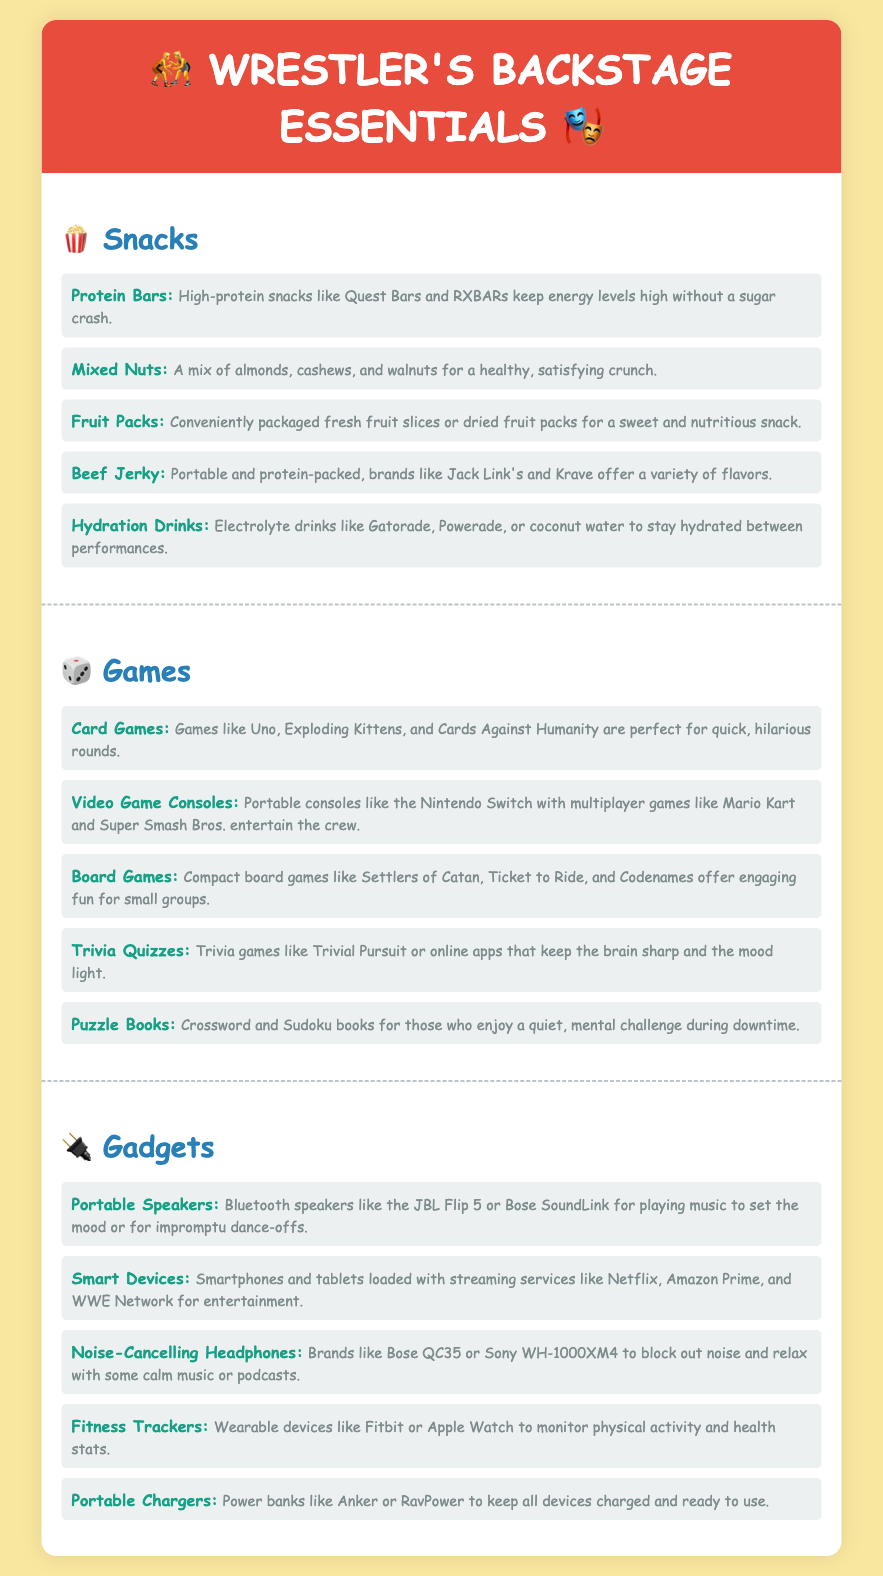what are the recommended snacks in the document? The snacks listed include Protein Bars, Mixed Nuts, Fruit Packs, Beef Jerky, and Hydration Drinks.
Answer: Protein Bars, Mixed Nuts, Fruit Packs, Beef Jerky, Hydration Drinks which game involves playing with cards and can include a surprising outcome? Card Games like Uno and Exploding Kittens provide quick, humorous rounds of play.
Answer: Card Games how many different types of gadgets are listed? The document includes a total of five gadget types in the Gadgets section.
Answer: Five what kind of drink is suggested for hydration? Hydration Drinks are suggested, specifically mentioning Gatorade, Powerade, and coconut water.
Answer: Hydration Drinks which portable device is mentioned for music enjoyment? Portable Speakers like the JBL Flip 5 or Bose SoundLink are recommended for music.
Answer: Portable Speakers what kind of gaming system is highlighted for playing multiplayer games? The document mentions Portable consoles, specifically the Nintendo Switch, for multiplayer gaming.
Answer: Nintendo Switch how many snacks are listed in total? The document lists five snacks under the Snacks section.
Answer: Five which game mentioned is suitable for small groups and involves strategy? Compact board games such as Settlers of Catan are suited for engaging fun with small groups.
Answer: Settlers of Catan which gadget is said to help monitor physical activity? Fitness Trackers like Fitbit or Apple Watch are designed to monitor physical activity.
Answer: Fitness Trackers 